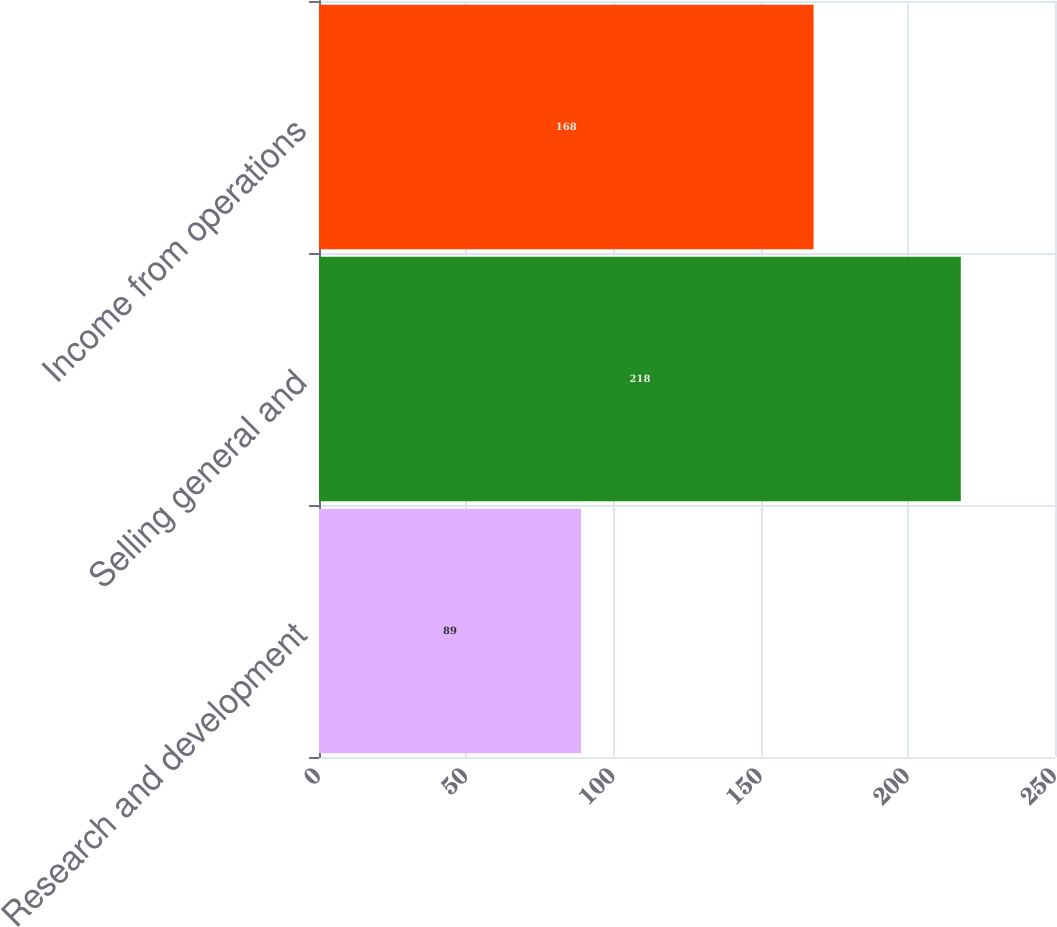Convert chart to OTSL. <chart><loc_0><loc_0><loc_500><loc_500><bar_chart><fcel>Research and development<fcel>Selling general and<fcel>Income from operations<nl><fcel>89<fcel>218<fcel>168<nl></chart> 